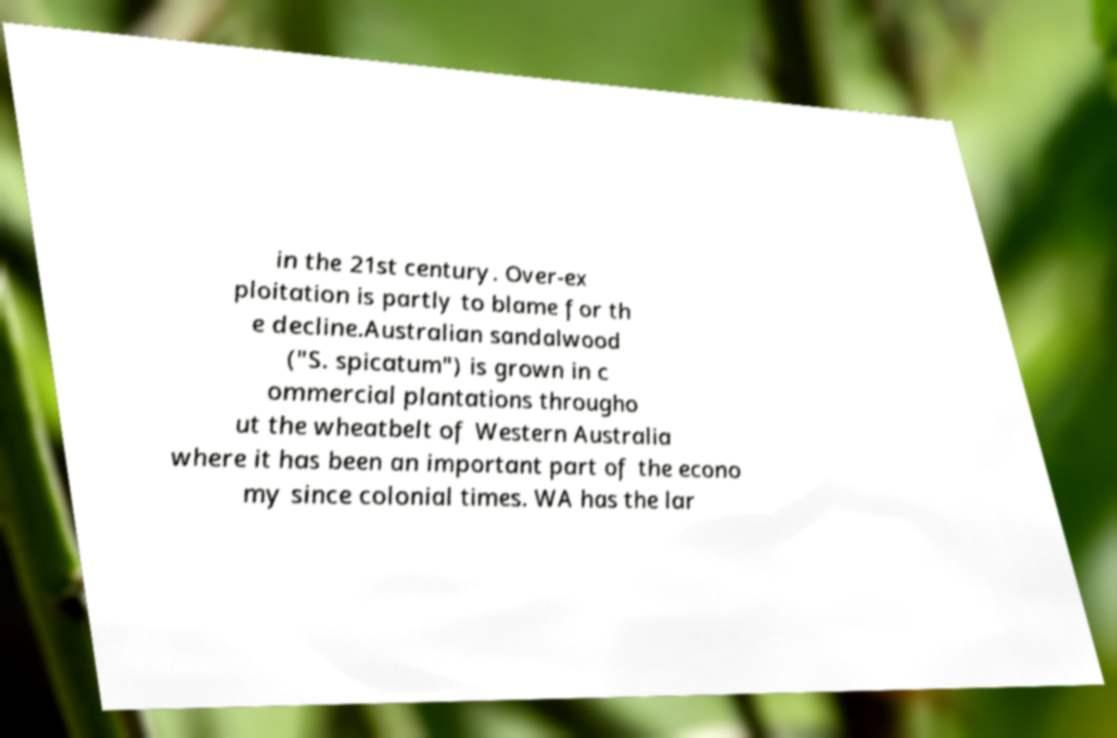Please read and relay the text visible in this image. What does it say? in the 21st century. Over-ex ploitation is partly to blame for th e decline.Australian sandalwood ("S. spicatum") is grown in c ommercial plantations througho ut the wheatbelt of Western Australia where it has been an important part of the econo my since colonial times. WA has the lar 